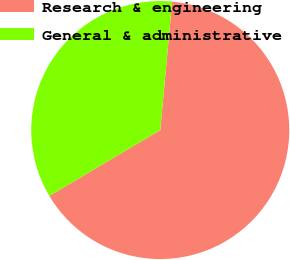<chart> <loc_0><loc_0><loc_500><loc_500><pie_chart><fcel>Research & engineering<fcel>General & administrative<nl><fcel>65.0%<fcel>35.0%<nl></chart> 